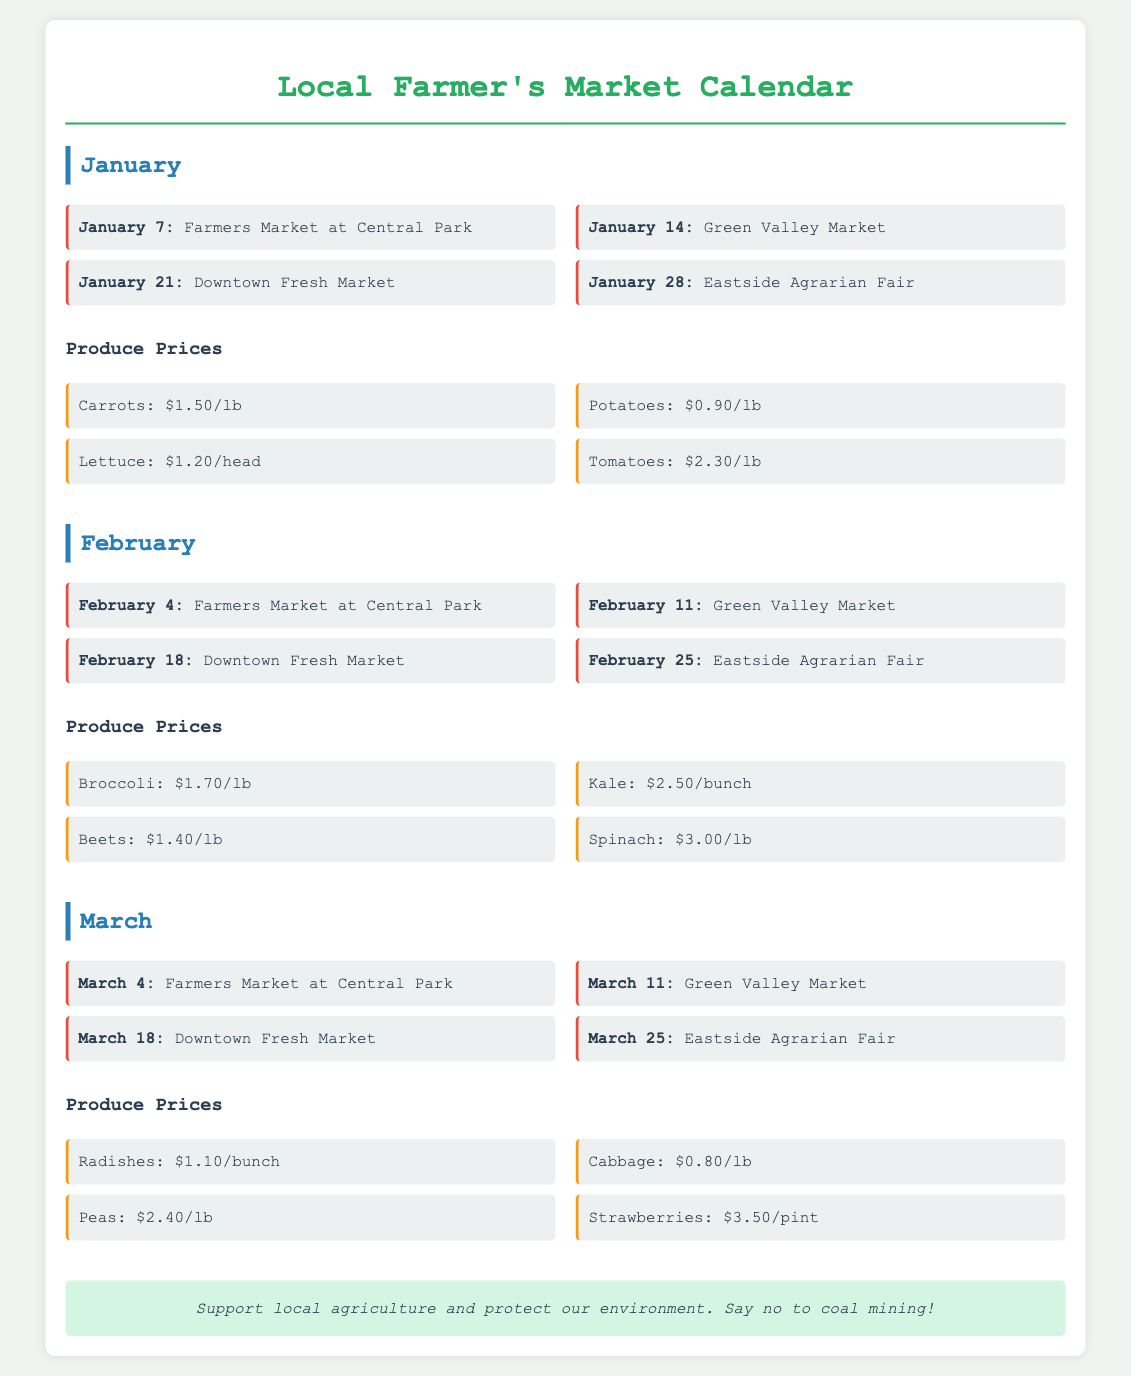what is the first market date in January? The first market date listed for January is January 7 at Central Park.
Answer: January 7 how much do carrots sell for per pound? The price for carrots is listed as $1.50 per pound.
Answer: $1.50/lb which produce item is the most expensive in February? In February, spinach is the most expensive produce item at $3.00 per pound.
Answer: Spinach how many market dates are listed for March? There are four market dates listed for March.
Answer: Four what is the price for tomatoes? The price listed for tomatoes is $2.30 per pound.
Answer: $2.30/lb where is the Farmers Market located on February 4? The Farmers Market on February 4 is at Central Park.
Answer: Central Park which produce item has the lowest price in January? The lowest priced item in January is potatoes at $0.90 per pound.
Answer: Potatoes: $0.90/lb what is the date of the last market in January? The last market date listed in January is January 28 for the Eastside Agrarian Fair.
Answer: January 28 how much do beets sell for per pound in February? Beets are priced at $1.40 per pound in February.
Answer: $1.40/lb 